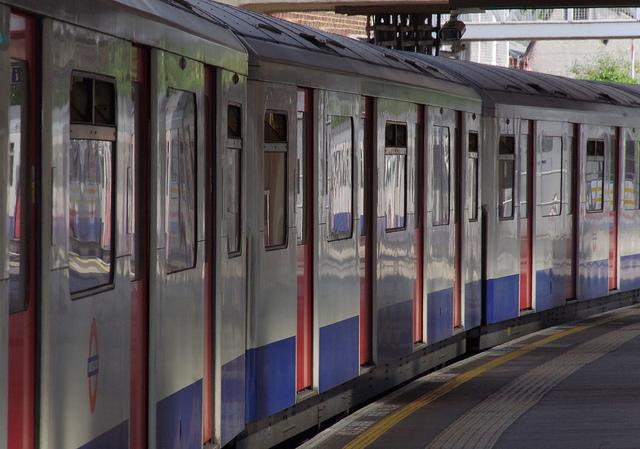Are the doors closed?
Quick response, please. Yes. What colors is the train?
Keep it brief. Gray, red, and blue. How many windows are open?
Quick response, please. 7. 